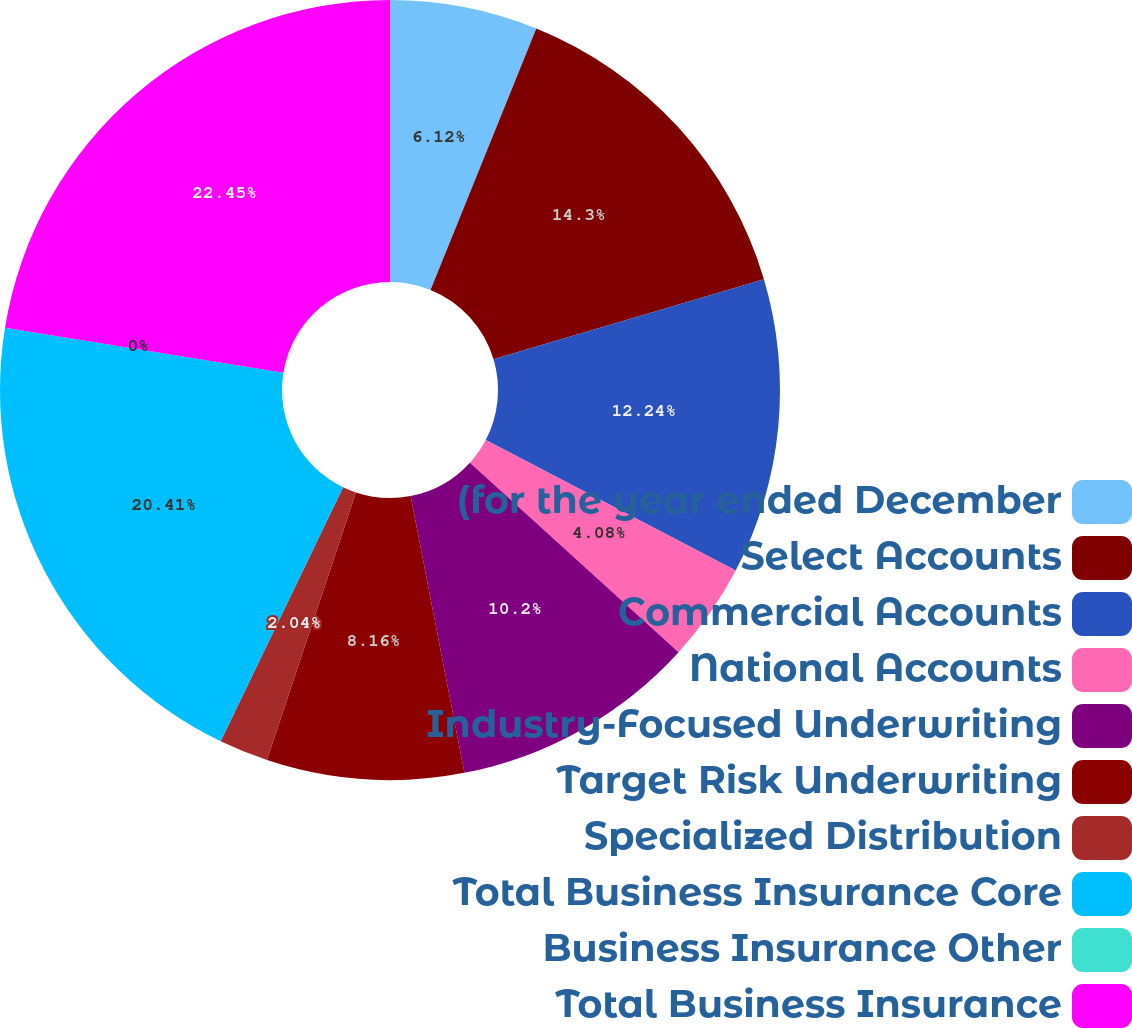Convert chart to OTSL. <chart><loc_0><loc_0><loc_500><loc_500><pie_chart><fcel>(for the year ended December<fcel>Select Accounts<fcel>Commercial Accounts<fcel>National Accounts<fcel>Industry-Focused Underwriting<fcel>Target Risk Underwriting<fcel>Specialized Distribution<fcel>Total Business Insurance Core<fcel>Business Insurance Other<fcel>Total Business Insurance<nl><fcel>6.12%<fcel>14.29%<fcel>12.24%<fcel>4.08%<fcel>10.2%<fcel>8.16%<fcel>2.04%<fcel>20.4%<fcel>0.0%<fcel>22.44%<nl></chart> 